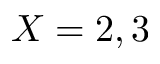<formula> <loc_0><loc_0><loc_500><loc_500>X = 2 , 3</formula> 